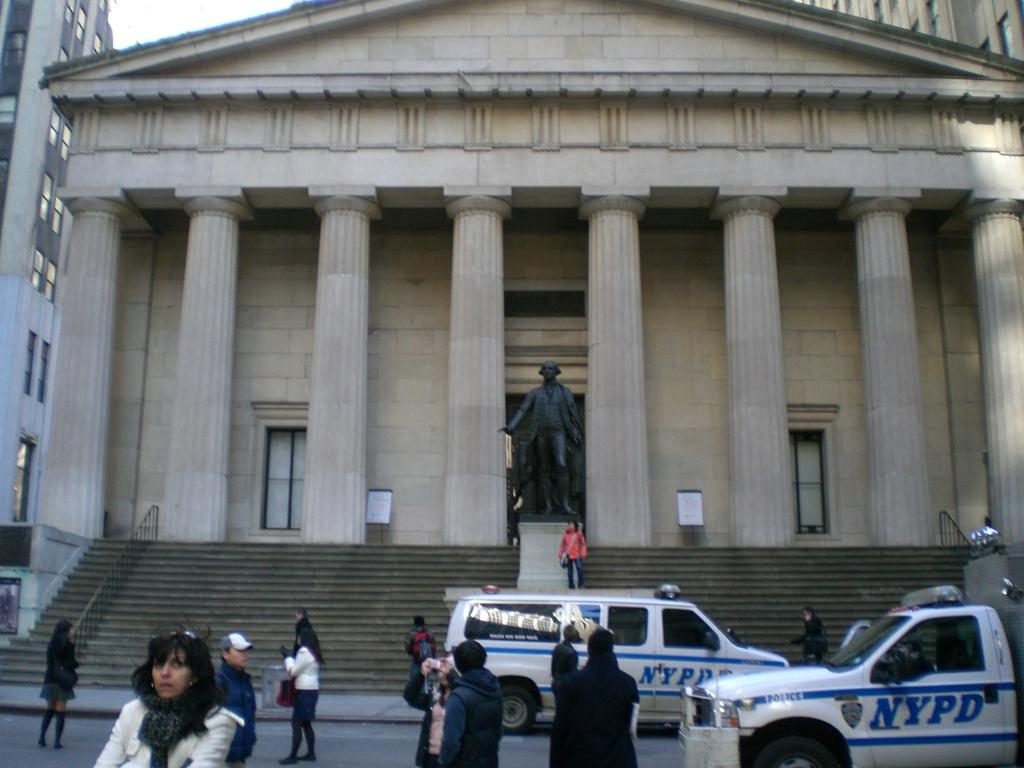Who or what can be seen in the image? There are people in the image. What else is present in the image besides people? There are vehicles, stairs, a sculpture, and buildings in the image. Can you describe the buildings in the image? The buildings have pillars, windows, and a door. What note is the cloud playing in the image? There is no cloud or musical instrument present in the image. How is the cloud being measured in the image? There is no cloud or measuring device present in the image. 